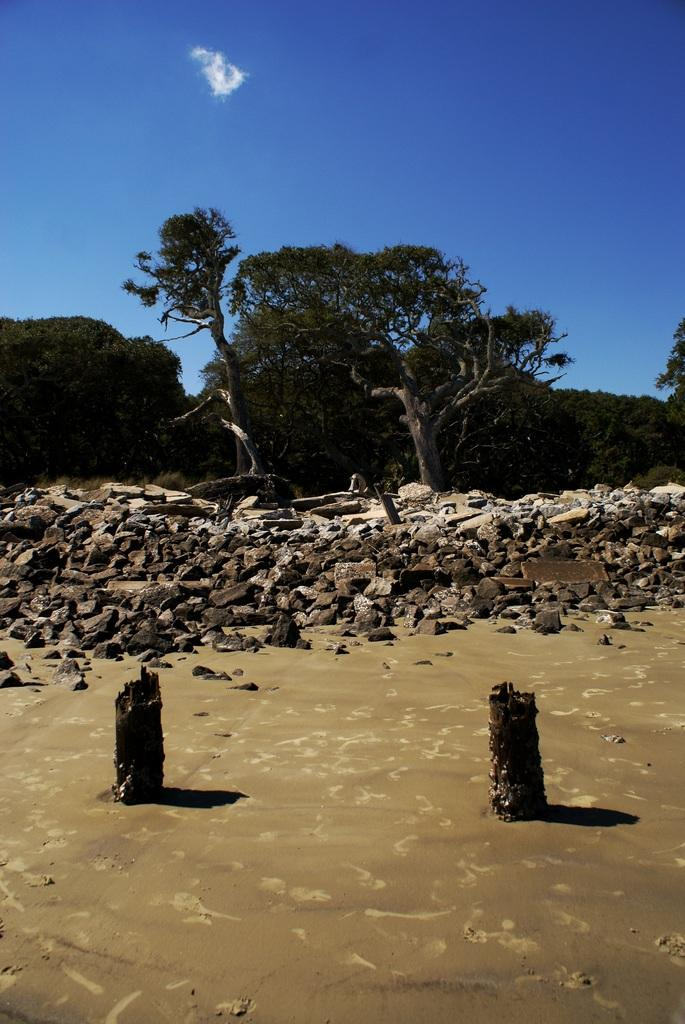What type of terrain is depicted in the image? There is mud and small stones in the image, suggesting a natural, possibly outdoor setting. What type of vegetation can be seen in the image? There are green color trees in the image. What is the color of the sky in the image? The sky is blue in the image. How many pieces of pie are visible in the image? There is no pie present in the image. Can you describe the cats in the image? There are no cats present in the image. 